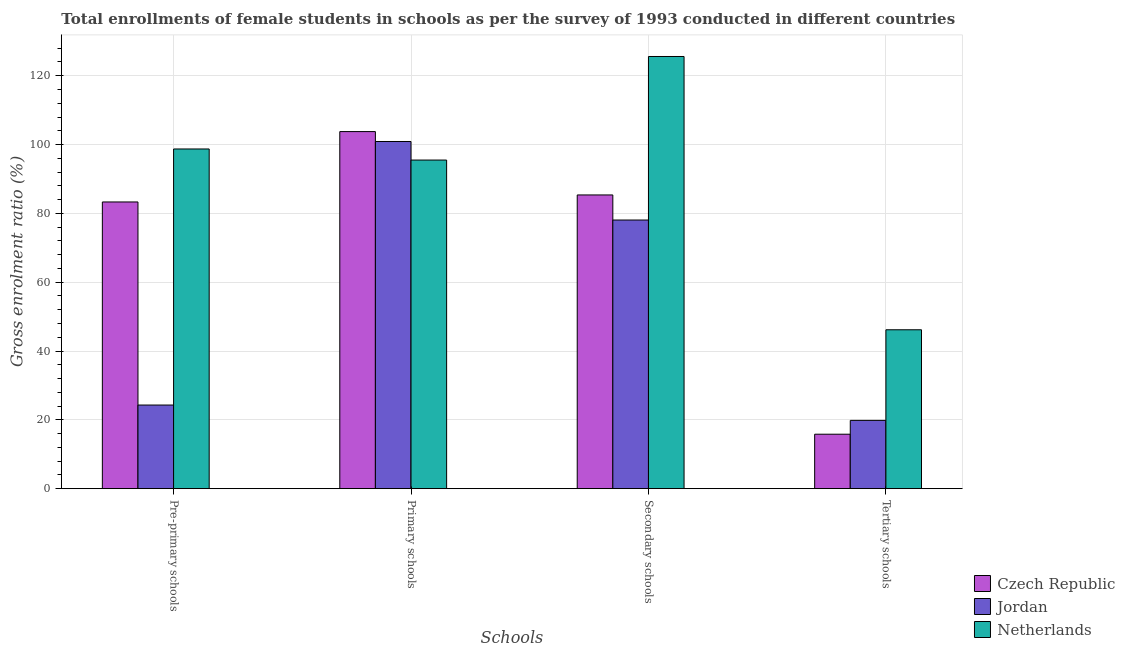How many groups of bars are there?
Keep it short and to the point. 4. Are the number of bars on each tick of the X-axis equal?
Provide a succinct answer. Yes. What is the label of the 4th group of bars from the left?
Make the answer very short. Tertiary schools. What is the gross enrolment ratio(female) in secondary schools in Czech Republic?
Your answer should be compact. 85.35. Across all countries, what is the maximum gross enrolment ratio(female) in tertiary schools?
Ensure brevity in your answer.  46.17. Across all countries, what is the minimum gross enrolment ratio(female) in secondary schools?
Provide a succinct answer. 78.06. In which country was the gross enrolment ratio(female) in secondary schools maximum?
Make the answer very short. Netherlands. In which country was the gross enrolment ratio(female) in secondary schools minimum?
Give a very brief answer. Jordan. What is the total gross enrolment ratio(female) in secondary schools in the graph?
Your answer should be very brief. 289. What is the difference between the gross enrolment ratio(female) in pre-primary schools in Netherlands and that in Czech Republic?
Give a very brief answer. 15.4. What is the difference between the gross enrolment ratio(female) in secondary schools in Czech Republic and the gross enrolment ratio(female) in pre-primary schools in Netherlands?
Your answer should be compact. -13.36. What is the average gross enrolment ratio(female) in primary schools per country?
Ensure brevity in your answer.  100.05. What is the difference between the gross enrolment ratio(female) in tertiary schools and gross enrolment ratio(female) in secondary schools in Czech Republic?
Provide a short and direct response. -69.53. In how many countries, is the gross enrolment ratio(female) in pre-primary schools greater than 44 %?
Keep it short and to the point. 2. What is the ratio of the gross enrolment ratio(female) in secondary schools in Netherlands to that in Jordan?
Offer a very short reply. 1.61. Is the gross enrolment ratio(female) in pre-primary schools in Jordan less than that in Netherlands?
Provide a short and direct response. Yes. Is the difference between the gross enrolment ratio(female) in tertiary schools in Czech Republic and Jordan greater than the difference between the gross enrolment ratio(female) in secondary schools in Czech Republic and Jordan?
Your response must be concise. No. What is the difference between the highest and the second highest gross enrolment ratio(female) in secondary schools?
Your answer should be very brief. 40.23. What is the difference between the highest and the lowest gross enrolment ratio(female) in primary schools?
Provide a succinct answer. 8.27. Is the sum of the gross enrolment ratio(female) in secondary schools in Czech Republic and Jordan greater than the maximum gross enrolment ratio(female) in pre-primary schools across all countries?
Make the answer very short. Yes. Is it the case that in every country, the sum of the gross enrolment ratio(female) in pre-primary schools and gross enrolment ratio(female) in secondary schools is greater than the sum of gross enrolment ratio(female) in tertiary schools and gross enrolment ratio(female) in primary schools?
Give a very brief answer. No. What does the 3rd bar from the left in Tertiary schools represents?
Your response must be concise. Netherlands. What does the 3rd bar from the right in Pre-primary schools represents?
Offer a very short reply. Czech Republic. Is it the case that in every country, the sum of the gross enrolment ratio(female) in pre-primary schools and gross enrolment ratio(female) in primary schools is greater than the gross enrolment ratio(female) in secondary schools?
Your response must be concise. Yes. Are all the bars in the graph horizontal?
Make the answer very short. No. What is the difference between two consecutive major ticks on the Y-axis?
Provide a succinct answer. 20. What is the title of the graph?
Offer a very short reply. Total enrollments of female students in schools as per the survey of 1993 conducted in different countries. What is the label or title of the X-axis?
Your answer should be compact. Schools. What is the Gross enrolment ratio (%) of Czech Republic in Pre-primary schools?
Keep it short and to the point. 83.32. What is the Gross enrolment ratio (%) in Jordan in Pre-primary schools?
Offer a very short reply. 24.3. What is the Gross enrolment ratio (%) of Netherlands in Pre-primary schools?
Keep it short and to the point. 98.71. What is the Gross enrolment ratio (%) of Czech Republic in Primary schools?
Your answer should be compact. 103.77. What is the Gross enrolment ratio (%) in Jordan in Primary schools?
Your answer should be compact. 100.89. What is the Gross enrolment ratio (%) of Netherlands in Primary schools?
Your answer should be compact. 95.49. What is the Gross enrolment ratio (%) of Czech Republic in Secondary schools?
Provide a short and direct response. 85.35. What is the Gross enrolment ratio (%) in Jordan in Secondary schools?
Keep it short and to the point. 78.06. What is the Gross enrolment ratio (%) of Netherlands in Secondary schools?
Your response must be concise. 125.59. What is the Gross enrolment ratio (%) in Czech Republic in Tertiary schools?
Offer a very short reply. 15.83. What is the Gross enrolment ratio (%) of Jordan in Tertiary schools?
Your answer should be compact. 19.85. What is the Gross enrolment ratio (%) in Netherlands in Tertiary schools?
Give a very brief answer. 46.17. Across all Schools, what is the maximum Gross enrolment ratio (%) of Czech Republic?
Your answer should be compact. 103.77. Across all Schools, what is the maximum Gross enrolment ratio (%) of Jordan?
Provide a succinct answer. 100.89. Across all Schools, what is the maximum Gross enrolment ratio (%) in Netherlands?
Provide a succinct answer. 125.59. Across all Schools, what is the minimum Gross enrolment ratio (%) of Czech Republic?
Provide a short and direct response. 15.83. Across all Schools, what is the minimum Gross enrolment ratio (%) of Jordan?
Provide a succinct answer. 19.85. Across all Schools, what is the minimum Gross enrolment ratio (%) in Netherlands?
Offer a very short reply. 46.17. What is the total Gross enrolment ratio (%) in Czech Republic in the graph?
Your answer should be compact. 288.26. What is the total Gross enrolment ratio (%) in Jordan in the graph?
Give a very brief answer. 223.1. What is the total Gross enrolment ratio (%) of Netherlands in the graph?
Your answer should be compact. 365.96. What is the difference between the Gross enrolment ratio (%) in Czech Republic in Pre-primary schools and that in Primary schools?
Your response must be concise. -20.45. What is the difference between the Gross enrolment ratio (%) of Jordan in Pre-primary schools and that in Primary schools?
Give a very brief answer. -76.58. What is the difference between the Gross enrolment ratio (%) of Netherlands in Pre-primary schools and that in Primary schools?
Offer a very short reply. 3.22. What is the difference between the Gross enrolment ratio (%) of Czech Republic in Pre-primary schools and that in Secondary schools?
Offer a terse response. -2.04. What is the difference between the Gross enrolment ratio (%) in Jordan in Pre-primary schools and that in Secondary schools?
Your answer should be very brief. -53.76. What is the difference between the Gross enrolment ratio (%) in Netherlands in Pre-primary schools and that in Secondary schools?
Provide a succinct answer. -26.88. What is the difference between the Gross enrolment ratio (%) in Czech Republic in Pre-primary schools and that in Tertiary schools?
Your answer should be compact. 67.49. What is the difference between the Gross enrolment ratio (%) of Jordan in Pre-primary schools and that in Tertiary schools?
Provide a short and direct response. 4.46. What is the difference between the Gross enrolment ratio (%) in Netherlands in Pre-primary schools and that in Tertiary schools?
Offer a very short reply. 52.54. What is the difference between the Gross enrolment ratio (%) in Czech Republic in Primary schools and that in Secondary schools?
Offer a very short reply. 18.41. What is the difference between the Gross enrolment ratio (%) in Jordan in Primary schools and that in Secondary schools?
Keep it short and to the point. 22.82. What is the difference between the Gross enrolment ratio (%) in Netherlands in Primary schools and that in Secondary schools?
Provide a succinct answer. -30.09. What is the difference between the Gross enrolment ratio (%) of Czech Republic in Primary schools and that in Tertiary schools?
Make the answer very short. 87.94. What is the difference between the Gross enrolment ratio (%) of Jordan in Primary schools and that in Tertiary schools?
Provide a short and direct response. 81.04. What is the difference between the Gross enrolment ratio (%) of Netherlands in Primary schools and that in Tertiary schools?
Offer a very short reply. 49.32. What is the difference between the Gross enrolment ratio (%) of Czech Republic in Secondary schools and that in Tertiary schools?
Make the answer very short. 69.53. What is the difference between the Gross enrolment ratio (%) of Jordan in Secondary schools and that in Tertiary schools?
Your response must be concise. 58.22. What is the difference between the Gross enrolment ratio (%) of Netherlands in Secondary schools and that in Tertiary schools?
Your answer should be very brief. 79.41. What is the difference between the Gross enrolment ratio (%) of Czech Republic in Pre-primary schools and the Gross enrolment ratio (%) of Jordan in Primary schools?
Provide a short and direct response. -17.57. What is the difference between the Gross enrolment ratio (%) of Czech Republic in Pre-primary schools and the Gross enrolment ratio (%) of Netherlands in Primary schools?
Offer a very short reply. -12.18. What is the difference between the Gross enrolment ratio (%) of Jordan in Pre-primary schools and the Gross enrolment ratio (%) of Netherlands in Primary schools?
Your answer should be compact. -71.19. What is the difference between the Gross enrolment ratio (%) in Czech Republic in Pre-primary schools and the Gross enrolment ratio (%) in Jordan in Secondary schools?
Your answer should be compact. 5.25. What is the difference between the Gross enrolment ratio (%) of Czech Republic in Pre-primary schools and the Gross enrolment ratio (%) of Netherlands in Secondary schools?
Ensure brevity in your answer.  -42.27. What is the difference between the Gross enrolment ratio (%) in Jordan in Pre-primary schools and the Gross enrolment ratio (%) in Netherlands in Secondary schools?
Keep it short and to the point. -101.28. What is the difference between the Gross enrolment ratio (%) in Czech Republic in Pre-primary schools and the Gross enrolment ratio (%) in Jordan in Tertiary schools?
Your response must be concise. 63.47. What is the difference between the Gross enrolment ratio (%) in Czech Republic in Pre-primary schools and the Gross enrolment ratio (%) in Netherlands in Tertiary schools?
Provide a short and direct response. 37.14. What is the difference between the Gross enrolment ratio (%) of Jordan in Pre-primary schools and the Gross enrolment ratio (%) of Netherlands in Tertiary schools?
Your answer should be very brief. -21.87. What is the difference between the Gross enrolment ratio (%) in Czech Republic in Primary schools and the Gross enrolment ratio (%) in Jordan in Secondary schools?
Offer a very short reply. 25.7. What is the difference between the Gross enrolment ratio (%) of Czech Republic in Primary schools and the Gross enrolment ratio (%) of Netherlands in Secondary schools?
Give a very brief answer. -21.82. What is the difference between the Gross enrolment ratio (%) in Jordan in Primary schools and the Gross enrolment ratio (%) in Netherlands in Secondary schools?
Offer a terse response. -24.7. What is the difference between the Gross enrolment ratio (%) of Czech Republic in Primary schools and the Gross enrolment ratio (%) of Jordan in Tertiary schools?
Provide a short and direct response. 83.92. What is the difference between the Gross enrolment ratio (%) of Czech Republic in Primary schools and the Gross enrolment ratio (%) of Netherlands in Tertiary schools?
Keep it short and to the point. 57.59. What is the difference between the Gross enrolment ratio (%) in Jordan in Primary schools and the Gross enrolment ratio (%) in Netherlands in Tertiary schools?
Your response must be concise. 54.71. What is the difference between the Gross enrolment ratio (%) in Czech Republic in Secondary schools and the Gross enrolment ratio (%) in Jordan in Tertiary schools?
Provide a succinct answer. 65.51. What is the difference between the Gross enrolment ratio (%) in Czech Republic in Secondary schools and the Gross enrolment ratio (%) in Netherlands in Tertiary schools?
Your response must be concise. 39.18. What is the difference between the Gross enrolment ratio (%) in Jordan in Secondary schools and the Gross enrolment ratio (%) in Netherlands in Tertiary schools?
Provide a succinct answer. 31.89. What is the average Gross enrolment ratio (%) of Czech Republic per Schools?
Your answer should be very brief. 72.07. What is the average Gross enrolment ratio (%) in Jordan per Schools?
Offer a very short reply. 55.77. What is the average Gross enrolment ratio (%) in Netherlands per Schools?
Keep it short and to the point. 91.49. What is the difference between the Gross enrolment ratio (%) in Czech Republic and Gross enrolment ratio (%) in Jordan in Pre-primary schools?
Offer a very short reply. 59.01. What is the difference between the Gross enrolment ratio (%) of Czech Republic and Gross enrolment ratio (%) of Netherlands in Pre-primary schools?
Offer a terse response. -15.4. What is the difference between the Gross enrolment ratio (%) of Jordan and Gross enrolment ratio (%) of Netherlands in Pre-primary schools?
Your response must be concise. -74.41. What is the difference between the Gross enrolment ratio (%) of Czech Republic and Gross enrolment ratio (%) of Jordan in Primary schools?
Give a very brief answer. 2.88. What is the difference between the Gross enrolment ratio (%) in Czech Republic and Gross enrolment ratio (%) in Netherlands in Primary schools?
Provide a succinct answer. 8.27. What is the difference between the Gross enrolment ratio (%) in Jordan and Gross enrolment ratio (%) in Netherlands in Primary schools?
Give a very brief answer. 5.39. What is the difference between the Gross enrolment ratio (%) of Czech Republic and Gross enrolment ratio (%) of Jordan in Secondary schools?
Your response must be concise. 7.29. What is the difference between the Gross enrolment ratio (%) of Czech Republic and Gross enrolment ratio (%) of Netherlands in Secondary schools?
Provide a short and direct response. -40.23. What is the difference between the Gross enrolment ratio (%) in Jordan and Gross enrolment ratio (%) in Netherlands in Secondary schools?
Keep it short and to the point. -47.52. What is the difference between the Gross enrolment ratio (%) in Czech Republic and Gross enrolment ratio (%) in Jordan in Tertiary schools?
Keep it short and to the point. -4.02. What is the difference between the Gross enrolment ratio (%) in Czech Republic and Gross enrolment ratio (%) in Netherlands in Tertiary schools?
Make the answer very short. -30.35. What is the difference between the Gross enrolment ratio (%) of Jordan and Gross enrolment ratio (%) of Netherlands in Tertiary schools?
Make the answer very short. -26.33. What is the ratio of the Gross enrolment ratio (%) in Czech Republic in Pre-primary schools to that in Primary schools?
Provide a succinct answer. 0.8. What is the ratio of the Gross enrolment ratio (%) of Jordan in Pre-primary schools to that in Primary schools?
Make the answer very short. 0.24. What is the ratio of the Gross enrolment ratio (%) in Netherlands in Pre-primary schools to that in Primary schools?
Your answer should be compact. 1.03. What is the ratio of the Gross enrolment ratio (%) in Czech Republic in Pre-primary schools to that in Secondary schools?
Your response must be concise. 0.98. What is the ratio of the Gross enrolment ratio (%) of Jordan in Pre-primary schools to that in Secondary schools?
Your answer should be very brief. 0.31. What is the ratio of the Gross enrolment ratio (%) in Netherlands in Pre-primary schools to that in Secondary schools?
Offer a terse response. 0.79. What is the ratio of the Gross enrolment ratio (%) in Czech Republic in Pre-primary schools to that in Tertiary schools?
Offer a terse response. 5.26. What is the ratio of the Gross enrolment ratio (%) of Jordan in Pre-primary schools to that in Tertiary schools?
Provide a succinct answer. 1.22. What is the ratio of the Gross enrolment ratio (%) of Netherlands in Pre-primary schools to that in Tertiary schools?
Your answer should be compact. 2.14. What is the ratio of the Gross enrolment ratio (%) of Czech Republic in Primary schools to that in Secondary schools?
Provide a short and direct response. 1.22. What is the ratio of the Gross enrolment ratio (%) of Jordan in Primary schools to that in Secondary schools?
Ensure brevity in your answer.  1.29. What is the ratio of the Gross enrolment ratio (%) of Netherlands in Primary schools to that in Secondary schools?
Give a very brief answer. 0.76. What is the ratio of the Gross enrolment ratio (%) in Czech Republic in Primary schools to that in Tertiary schools?
Offer a very short reply. 6.56. What is the ratio of the Gross enrolment ratio (%) in Jordan in Primary schools to that in Tertiary schools?
Give a very brief answer. 5.08. What is the ratio of the Gross enrolment ratio (%) of Netherlands in Primary schools to that in Tertiary schools?
Your answer should be very brief. 2.07. What is the ratio of the Gross enrolment ratio (%) in Czech Republic in Secondary schools to that in Tertiary schools?
Your answer should be compact. 5.39. What is the ratio of the Gross enrolment ratio (%) in Jordan in Secondary schools to that in Tertiary schools?
Ensure brevity in your answer.  3.93. What is the ratio of the Gross enrolment ratio (%) of Netherlands in Secondary schools to that in Tertiary schools?
Provide a succinct answer. 2.72. What is the difference between the highest and the second highest Gross enrolment ratio (%) in Czech Republic?
Your response must be concise. 18.41. What is the difference between the highest and the second highest Gross enrolment ratio (%) in Jordan?
Your answer should be compact. 22.82. What is the difference between the highest and the second highest Gross enrolment ratio (%) in Netherlands?
Your response must be concise. 26.88. What is the difference between the highest and the lowest Gross enrolment ratio (%) in Czech Republic?
Give a very brief answer. 87.94. What is the difference between the highest and the lowest Gross enrolment ratio (%) of Jordan?
Provide a succinct answer. 81.04. What is the difference between the highest and the lowest Gross enrolment ratio (%) in Netherlands?
Your response must be concise. 79.41. 